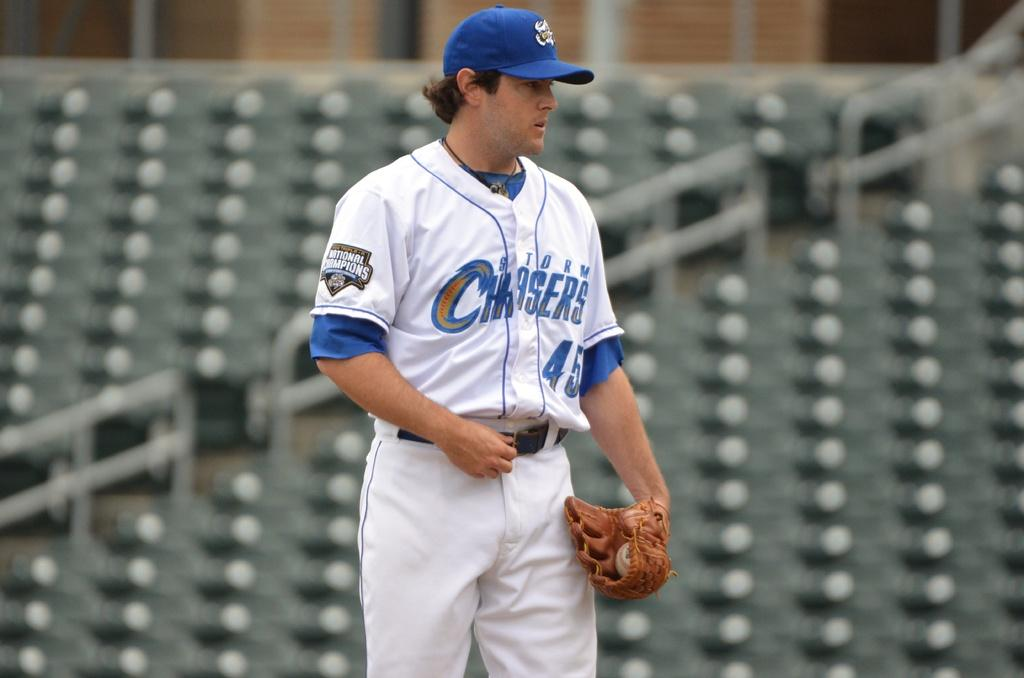<image>
Relay a brief, clear account of the picture shown. a person in a Storm Chasers 45 jersey looks to the side 